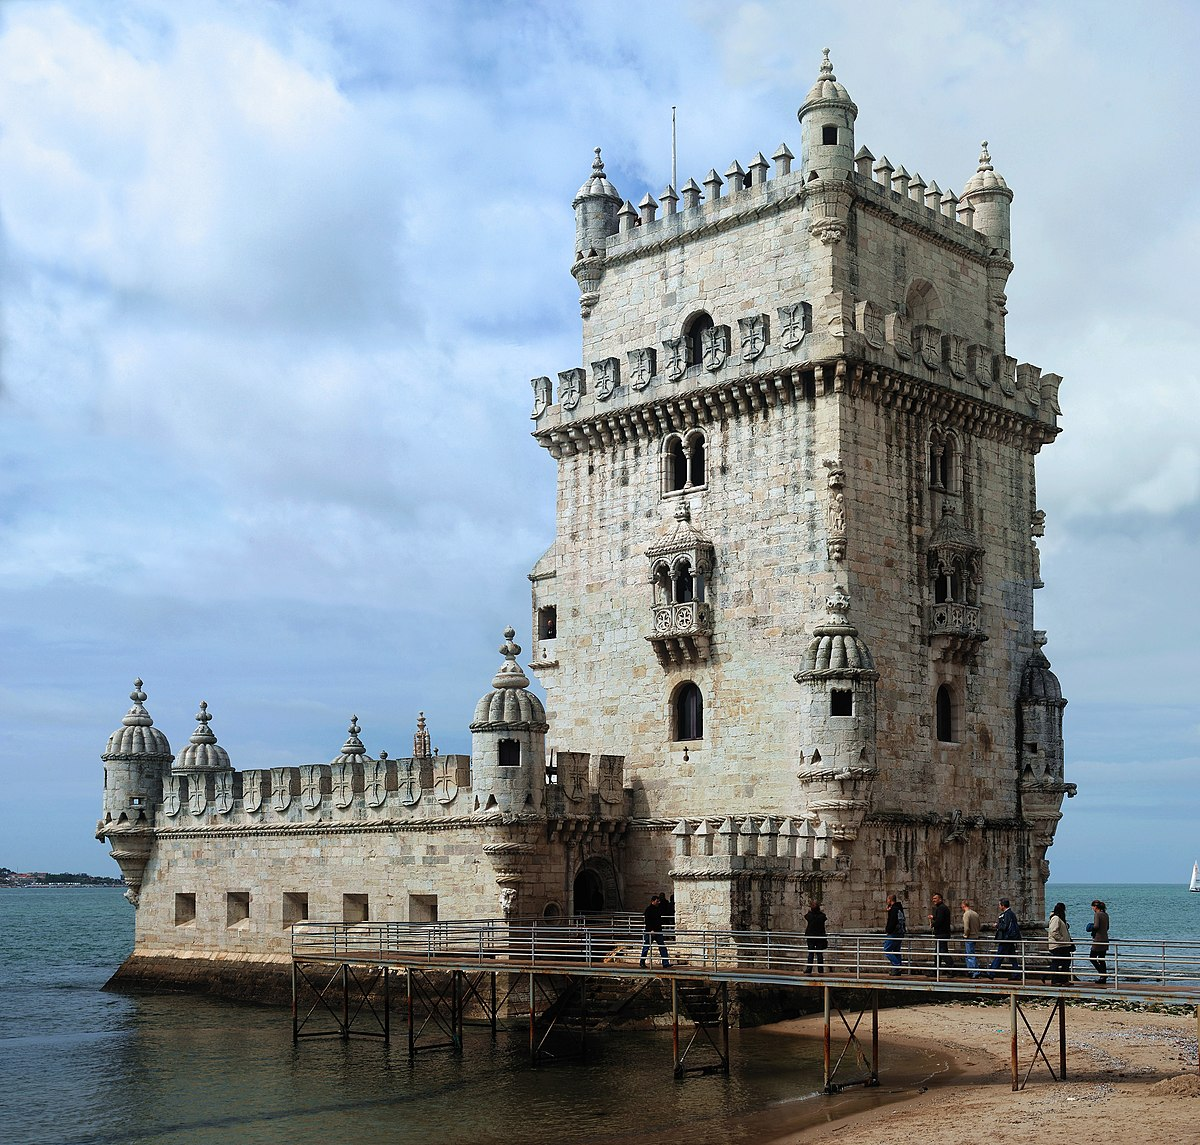Write a detailed description of the given image. The image beautifully captures the Belem Tower, a fortified monument located in Lisbon, Portugal. Known for its significant role in the Age of Discoveries, this UNESCO World Heritage Site is a prime example of the Portuguese Manueline style that incorporates ornate sculptural details reminiscent of the sea, such as twisted rope and armillary spheres.
The tower stands on a small beach, surrounded by water, which historically served as a point of embarkation and disembarkation for Portuguese explorers. The imposing square structure is made more intricate with its decorated turrets, watchtowers, and balconies. Each corner of the tower is adorned with a turret capped with a cupola, adding to its majestic appearance. The image captures a cloudy sky day, giving the scene a moody contrast against the bright stonework of the tower.
Visitors can be seen walking on a modern wooden bridge leading to the entrance, indicating its popularity and accessibility. This snapshot not only showcases the architectural beauty but also invokes the historical maritime significance, serving as a reminder of Portugal's navigational past. 